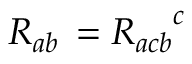Convert formula to latex. <formula><loc_0><loc_0><loc_500><loc_500>R _ { a b } \, = { R _ { a c b } } ^ { c }</formula> 